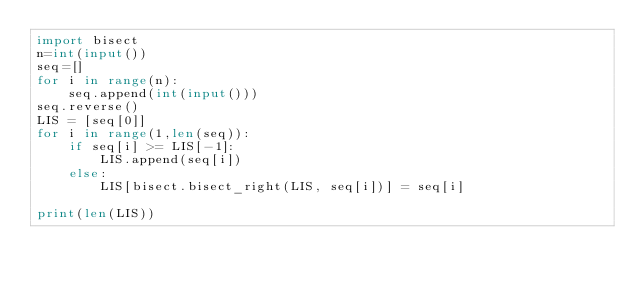<code> <loc_0><loc_0><loc_500><loc_500><_Python_>import bisect
n=int(input())
seq=[]
for i in range(n):
    seq.append(int(input()))
seq.reverse()
LIS = [seq[0]]
for i in range(1,len(seq)):
    if seq[i] >= LIS[-1]:
        LIS.append(seq[i])
    else:
        LIS[bisect.bisect_right(LIS, seq[i])] = seq[i]

print(len(LIS))
</code> 